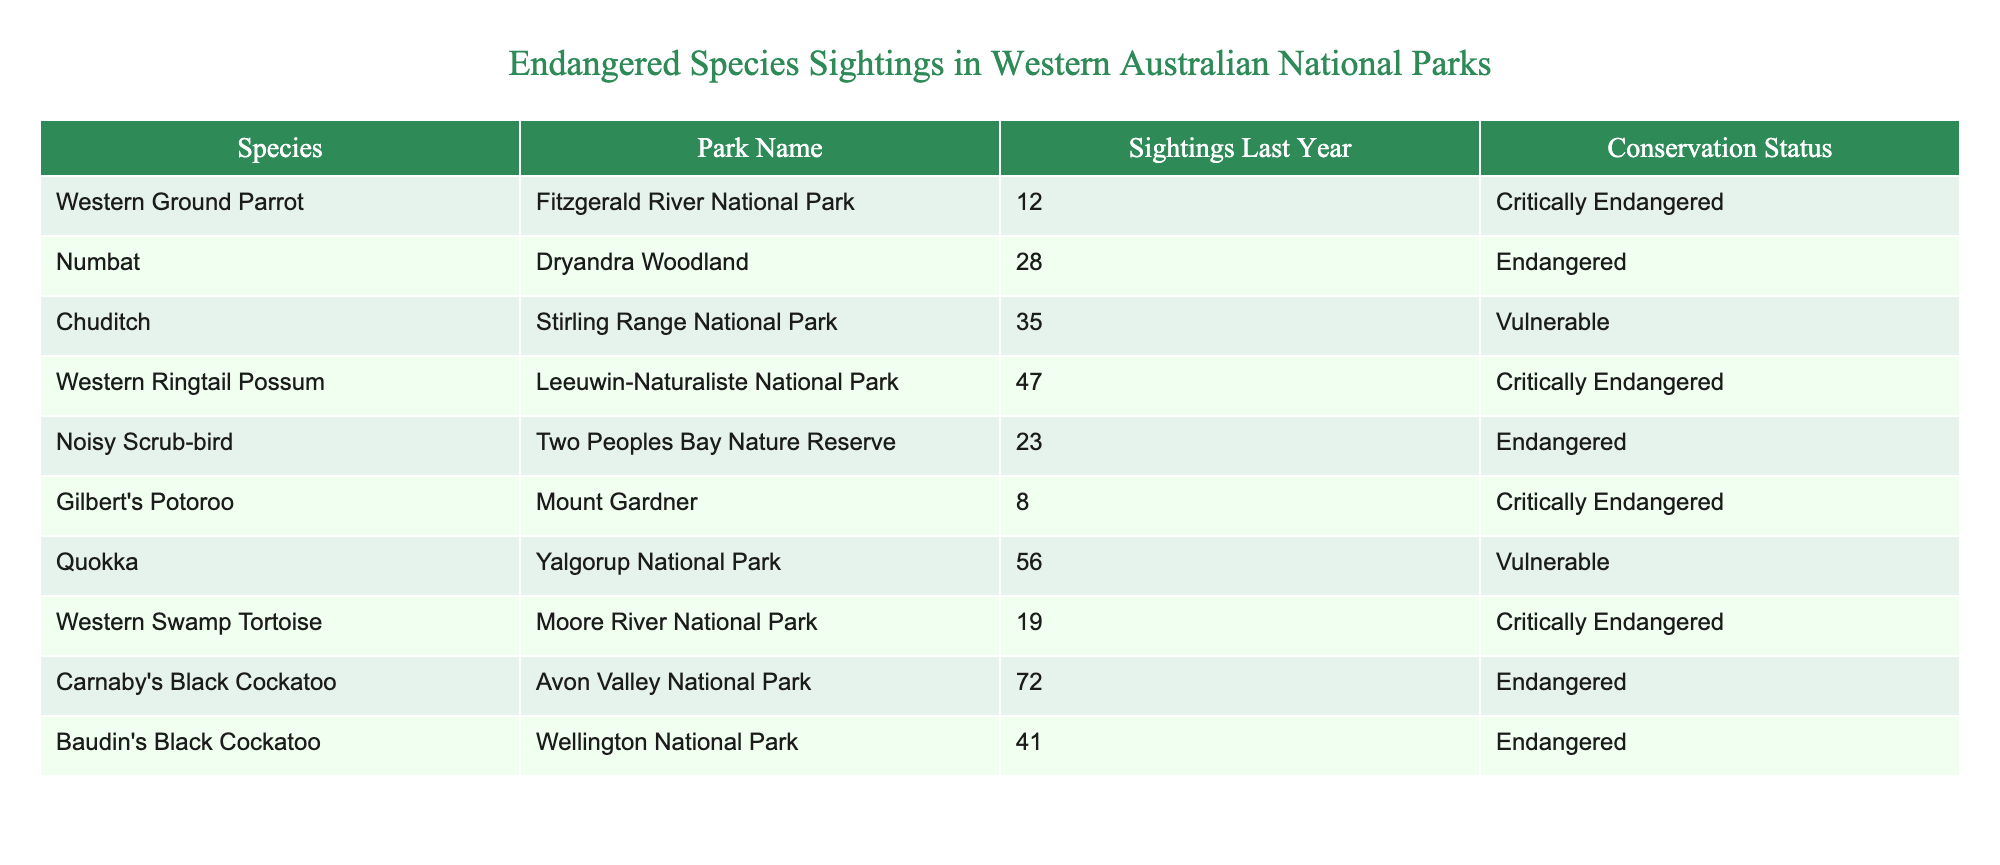What is the conservation status of the Gilbert's Potoroo? The conservation status of a species can be found in the "Conservation Status" column of the table. For Gilbert's Potoroo, it is listed as "Critically Endangered."
Answer: Critically Endangered Which park had the highest number of endangered species sightings last year? To find this, we compare the "Sightings Last Year" column for each park. Carnaby's Black Cockatoo at Avon Valley National Park had the highest at 72 sightings.
Answer: Avon Valley National Park Is the Western Ground Parrot more critically endangered than the Numbat? The conservation status can be found in the table. The Western Ground Parrot is "Critically Endangered" while the Numbat is "Endangered," indicating that the Western Ground Parrot is indeed more critically endangered.
Answer: Yes What is the total number of sightings for all Critically Endangered species combined? First, we identify all species with "Critically Endangered" status: Western Ground Parrot (12), Western Ringtail Possum (47), Gilbert's Potoroo (8), and Western Swamp Tortoise (19). Adding these sightings together (12 + 47 + 8 + 19) gives us 86.
Answer: 86 What is the average number of sightings for species classified as Vulnerable? The vulnerable species are Chuditch (35 sightings) and Quokka (56 sightings). We calculate the average by adding the sightings (35 + 56) which equals 91, then divide by the number of vulnerable species (2). The average is therefore 91/2 = 45.5.
Answer: 45.5 How many more sightings were recorded for Carnaby's Black Cockatoo than for the Noisy Scrub-bird? We find the number of sightings for each: Carnaby's Black Cockatoo had 72 and the Noisy Scrub-bird had 23. To find the difference, we subtract: 72 - 23 = 49.
Answer: 49 Does Two Peoples Bay Nature Reserve have more or less than 30 sightings? Checking the "Sightings Last Year" column for Two Peoples Bay Nature Reserve, we see it had 23 sightings, which is less than 30.
Answer: Less Which species had sightings closest to the average sightings across all species? To determine the average, we sum all sightings (12 + 28 + 35 + 47 + 23 + 8 + 56 + 19 + 72 + 41) = 341, and there are 10 species, making the average 341/10 = 34.1. The species closest to this value is Numbat with 28 sightings and Chuditch with 35 sightings, making both fairly close.
Answer: Numbat and Chuditch 